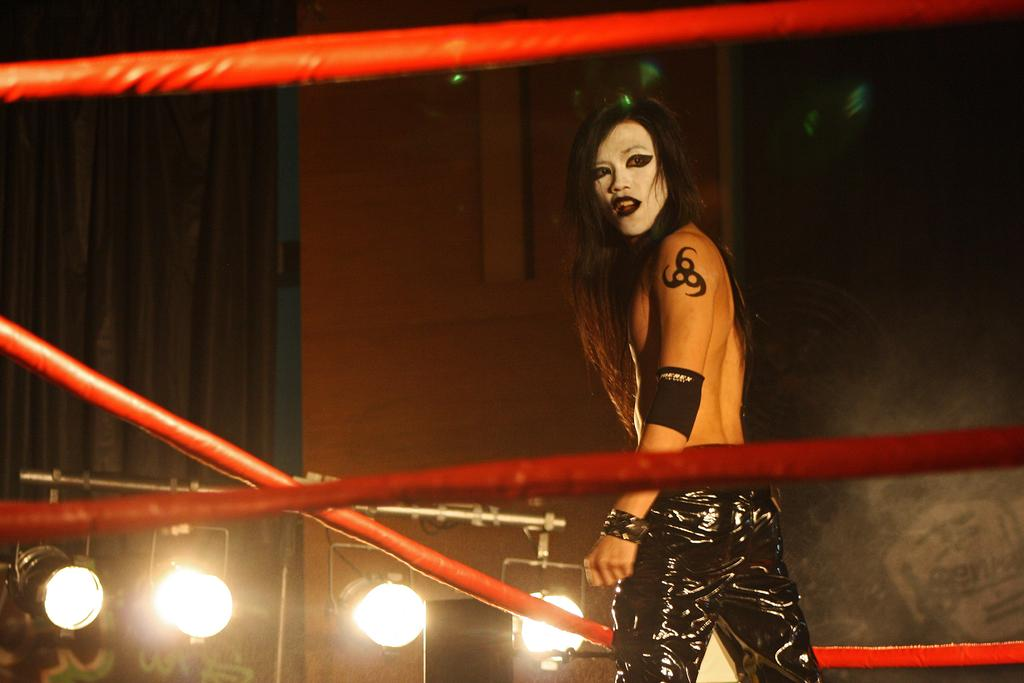What is the main subject of the image? There is a person in the image. What is the person wearing? The person is wearing black pants. How is the person's face depicted? The person's face is colored. What setting does the image appear to depict? The image appears to depict a boxing ring. What can be seen in the background of the image? There are lights and a wall in the background of the image. What month is being represented in the image? The image does not depict a specific month; it is a snapshot of a person in a boxing ring. How does the image address the issue of pollution? The image does not address the issue of pollution; it focuses on a person in a boxing ring. 